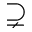<formula> <loc_0><loc_0><loc_500><loc_500>\supsetneq</formula> 